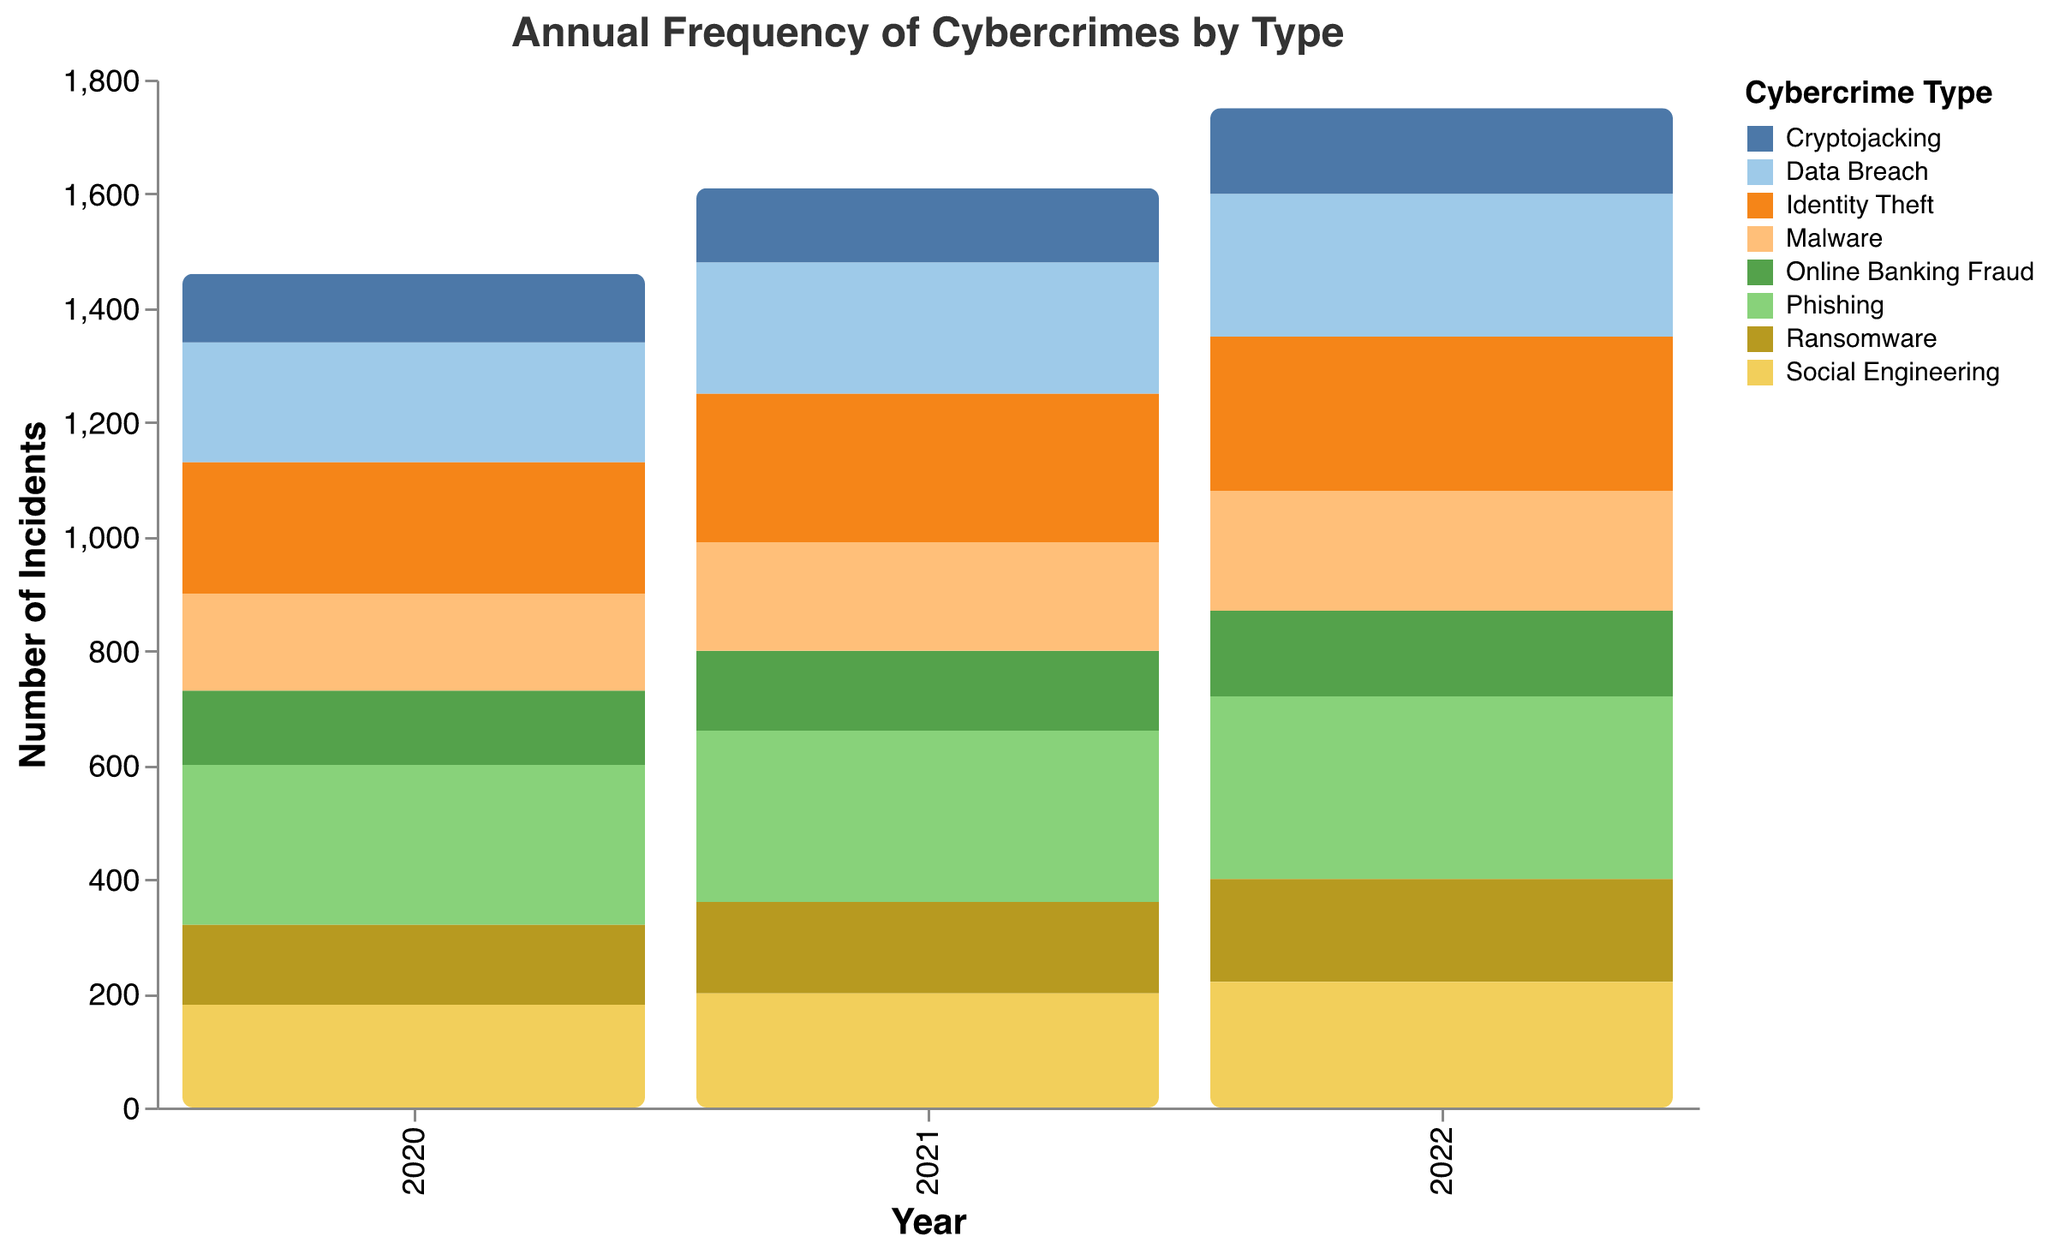What is the title of this plot? The title of the plot is displayed at the top and reads "Annual Frequency of Cybercrimes by Type".
Answer: Annual Frequency of Cybercrimes by Type What is the highest reported cybercrime type in 2022? By looking at the heights of the bars for 2022, the Phishing bar is the tallest, indicating the highest count.
Answer: Phishing Which year had the lowest number of Cryptojacking incidents? By comparing the heights of the Cryptojacking bars across all years, the shortest bar appears in 2020.
Answer: 2020 How many different types of cybercrimes are shown in the plot? Each color on the plot represents a different type of cybercrime, and the legend identifies 8 distinct types.
Answer: 8 What is the total number of Phishing incidents reported from 2020 to 2022? Add the number of Phishing incidents for each year: 280 (2020) + 300 (2021) + 320 (2022).
Answer: 900 How do the number of Social Engineering incidents in 2020 and 2022 compare? Visual comparison of the bars for Social Engineering in 2020 and 2022 shows that the 2022 bar is taller than the 2020 bar, indicating a higher count.
Answer: Higher in 2022 What is the percentage increase in Data Breach incidents from 2021 to 2022? Calculate the difference and then the percentage increase: (250 - 230)/230 * 100 = 8.70%.
Answer: 8.70% Which cybercrime type had the most significant increase in incidents from 2020 to 2022? Compare the differences in heights between the bars from 2020 to 2022 for each type. Phishing shows the largest increase.
Answer: Phishing What is the average number of Identity Theft incidents reported per year? Calculate the average by summing Identity Theft incidents over the three years and dividing by 3: (230 + 260 + 270) / 3.
Answer: 253.33 Are there any cybercrime categories with equal incident counts in any year? Look for bars that match in height within the same year. Both Online Banking Fraud and Cryptojacking have the same counts in 2022 (150 each).
Answer: Online Banking Fraud and Cryptojacking in 2022 